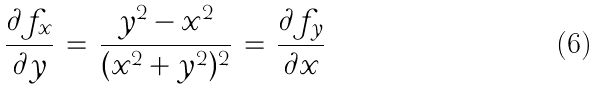Convert formula to latex. <formula><loc_0><loc_0><loc_500><loc_500>\frac { \partial f _ { x } } { \partial y } \, = \, \frac { y ^ { 2 } - x ^ { 2 } } { ( x ^ { 2 } + y ^ { 2 } ) ^ { 2 } } \, = \, \frac { \partial f _ { y } } { \partial x }</formula> 